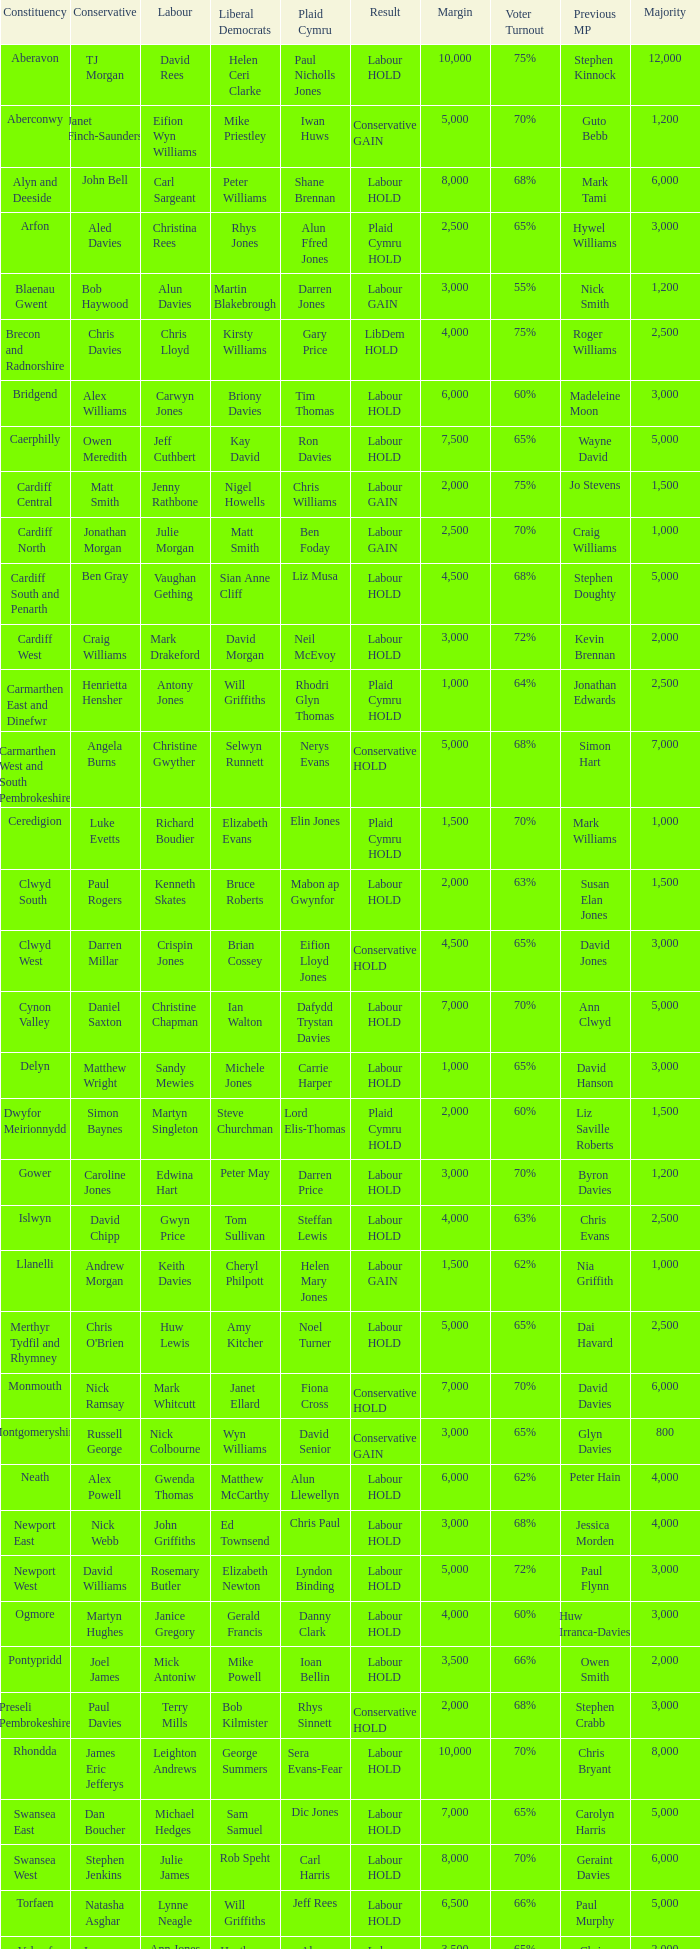What constituency does the Conservative Darren Millar belong to? Clwyd West. 